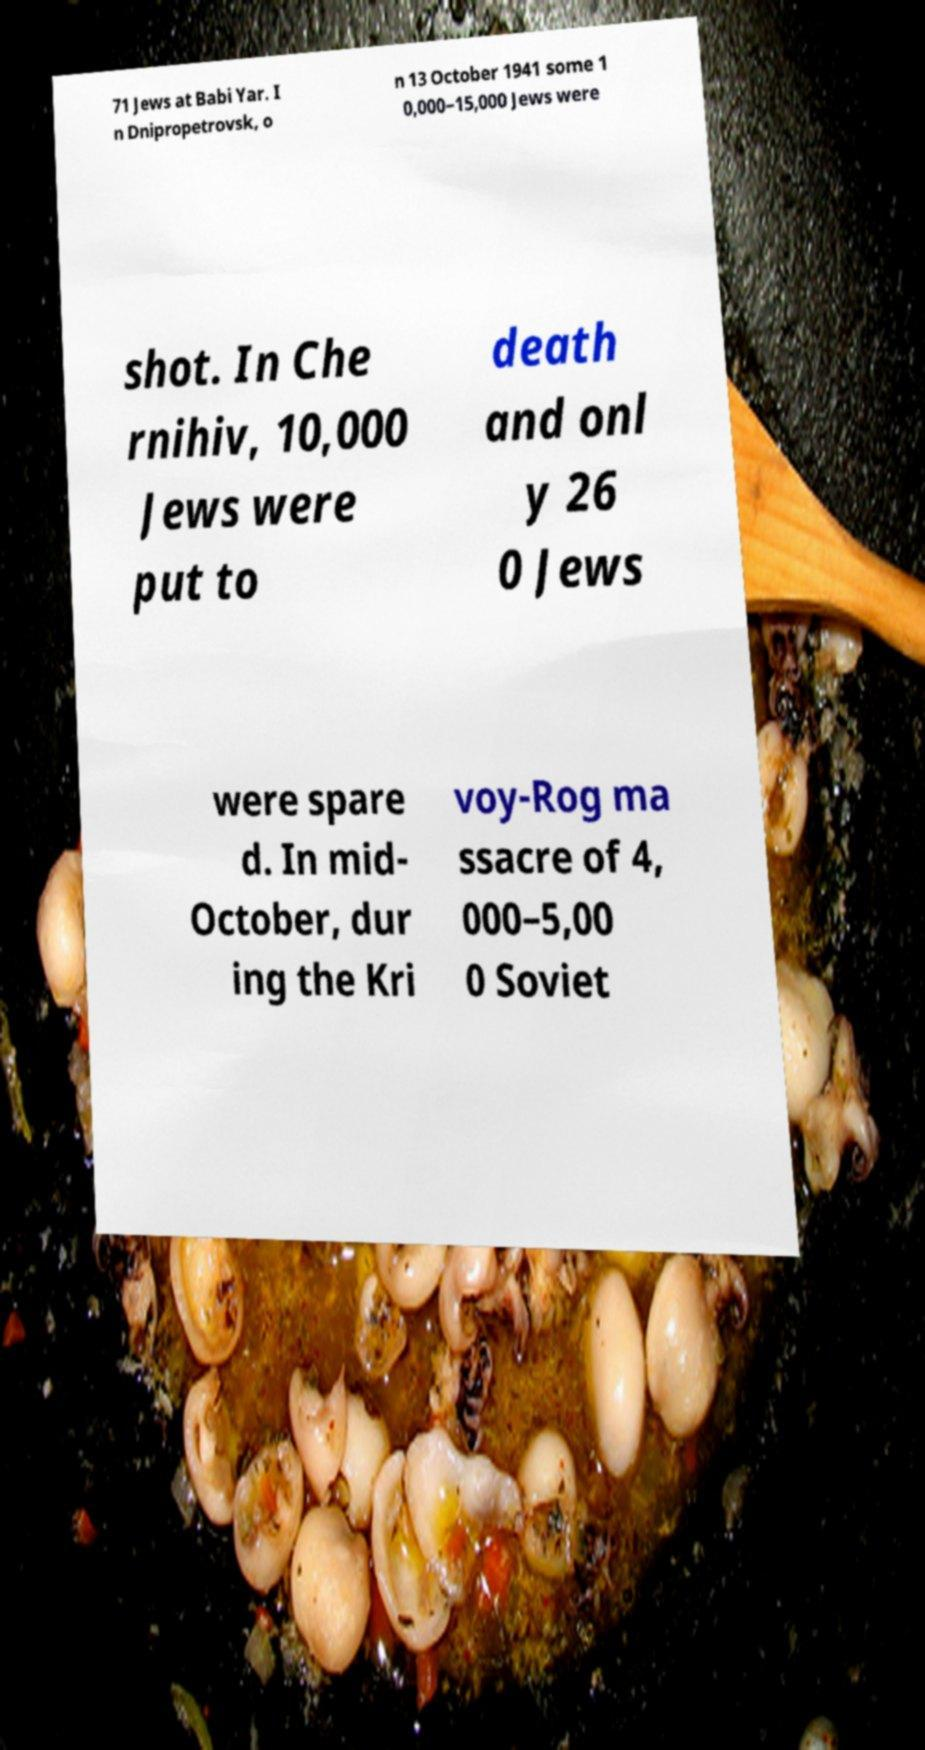Please read and relay the text visible in this image. What does it say? 71 Jews at Babi Yar. I n Dnipropetrovsk, o n 13 October 1941 some 1 0,000–15,000 Jews were shot. In Che rnihiv, 10,000 Jews were put to death and onl y 26 0 Jews were spare d. In mid- October, dur ing the Kri voy-Rog ma ssacre of 4, 000–5,00 0 Soviet 